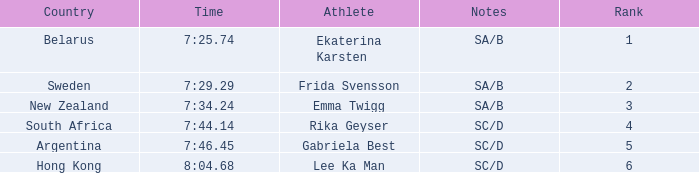What is the race time for emma twigg? 7:34.24. 